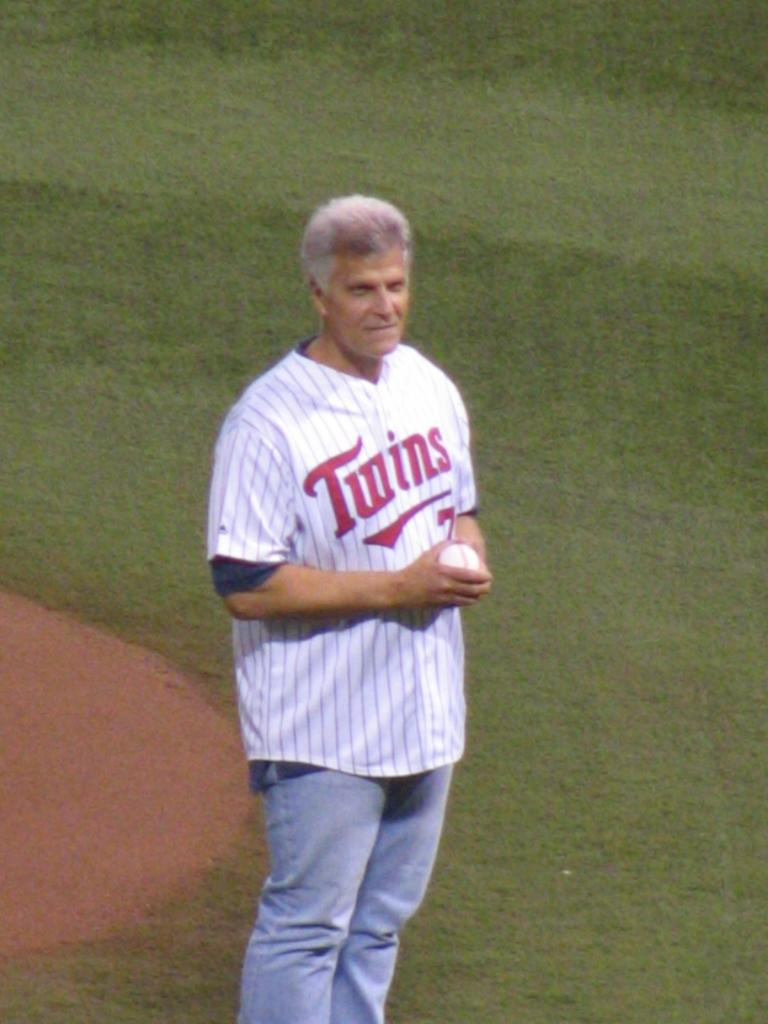<image>
Describe the image concisely. a man in a twins baseball jersey holding the ball 